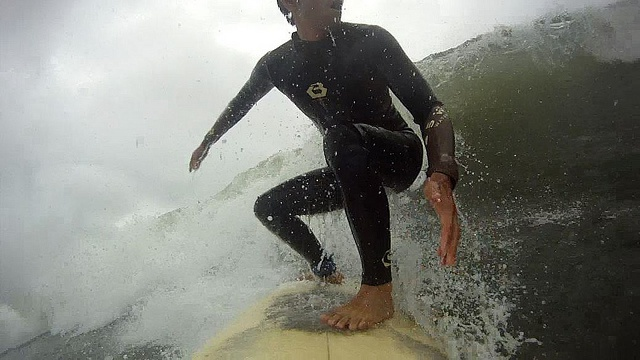Describe the objects in this image and their specific colors. I can see people in darkgray, black, gray, and maroon tones and surfboard in darkgray, tan, and gray tones in this image. 